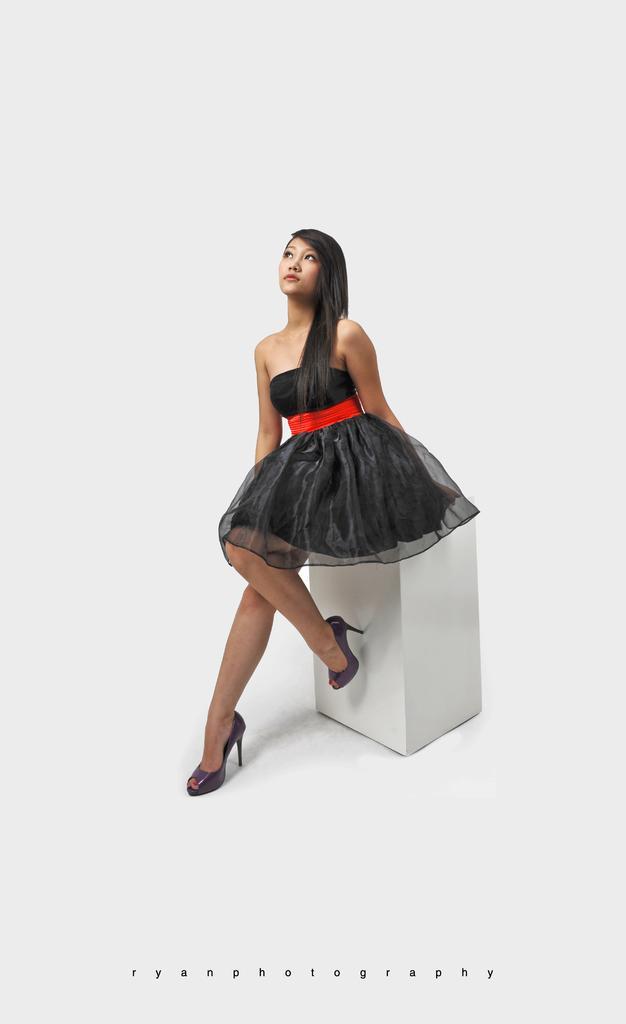Could you give a brief overview of what you see in this image? In the image I can see a lady who is sitting on the cube stool which is in white color. 